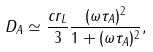<formula> <loc_0><loc_0><loc_500><loc_500>D _ { A } \simeq \frac { c r _ { L } } { 3 } \frac { ( \omega \tau _ { A } ) ^ { 2 } } { 1 + ( \omega \tau _ { A } ) ^ { 2 } } ,</formula> 